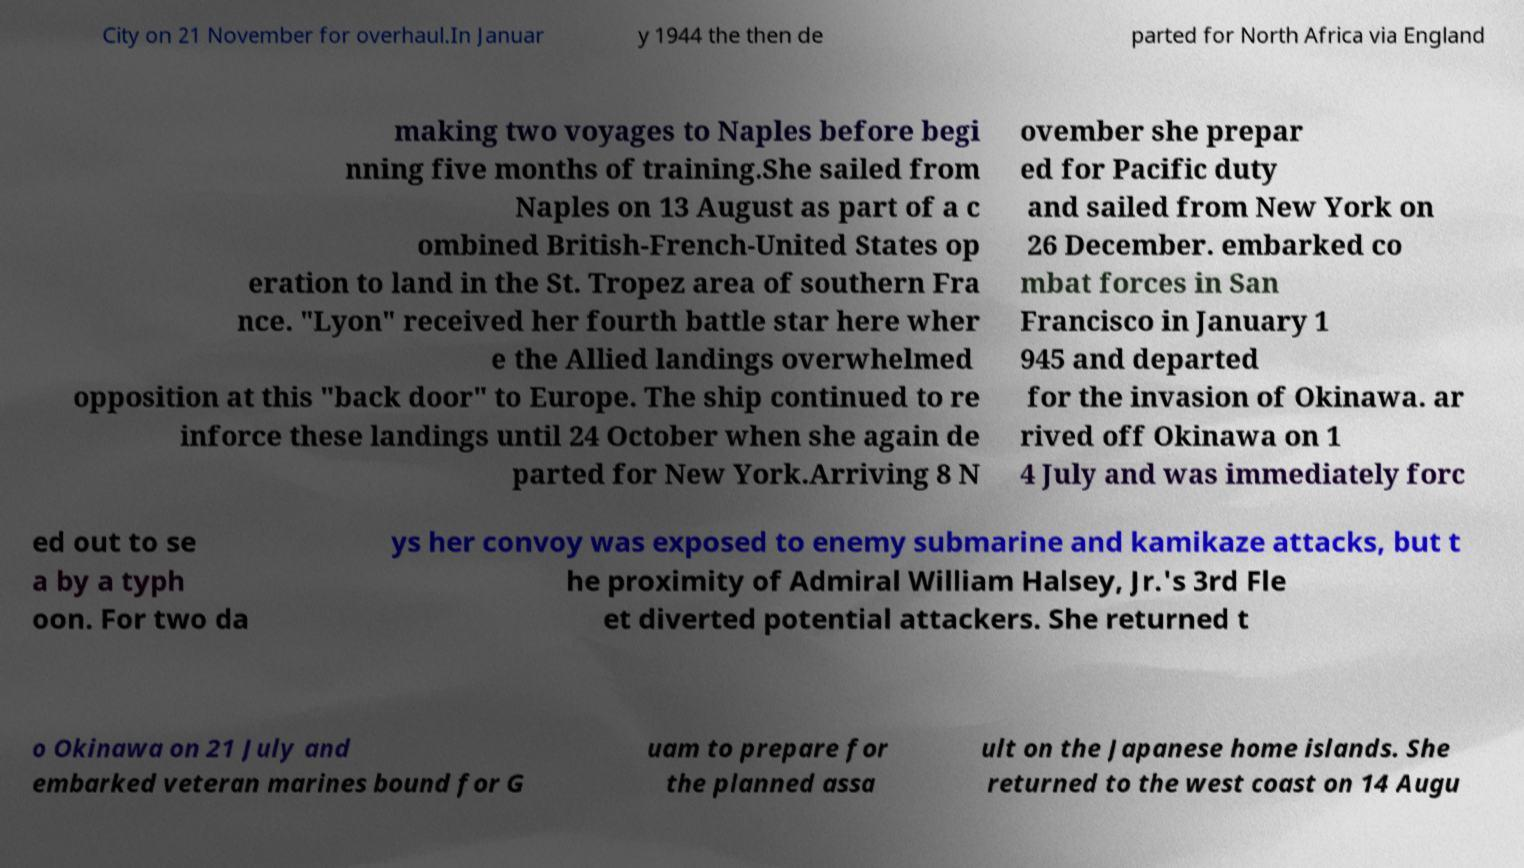Please identify and transcribe the text found in this image. City on 21 November for overhaul.In Januar y 1944 the then de parted for North Africa via England making two voyages to Naples before begi nning five months of training.She sailed from Naples on 13 August as part of a c ombined British-French-United States op eration to land in the St. Tropez area of southern Fra nce. "Lyon" received her fourth battle star here wher e the Allied landings overwhelmed opposition at this "back door" to Europe. The ship continued to re inforce these landings until 24 October when she again de parted for New York.Arriving 8 N ovember she prepar ed for Pacific duty and sailed from New York on 26 December. embarked co mbat forces in San Francisco in January 1 945 and departed for the invasion of Okinawa. ar rived off Okinawa on 1 4 July and was immediately forc ed out to se a by a typh oon. For two da ys her convoy was exposed to enemy submarine and kamikaze attacks, but t he proximity of Admiral William Halsey, Jr.'s 3rd Fle et diverted potential attackers. She returned t o Okinawa on 21 July and embarked veteran marines bound for G uam to prepare for the planned assa ult on the Japanese home islands. She returned to the west coast on 14 Augu 